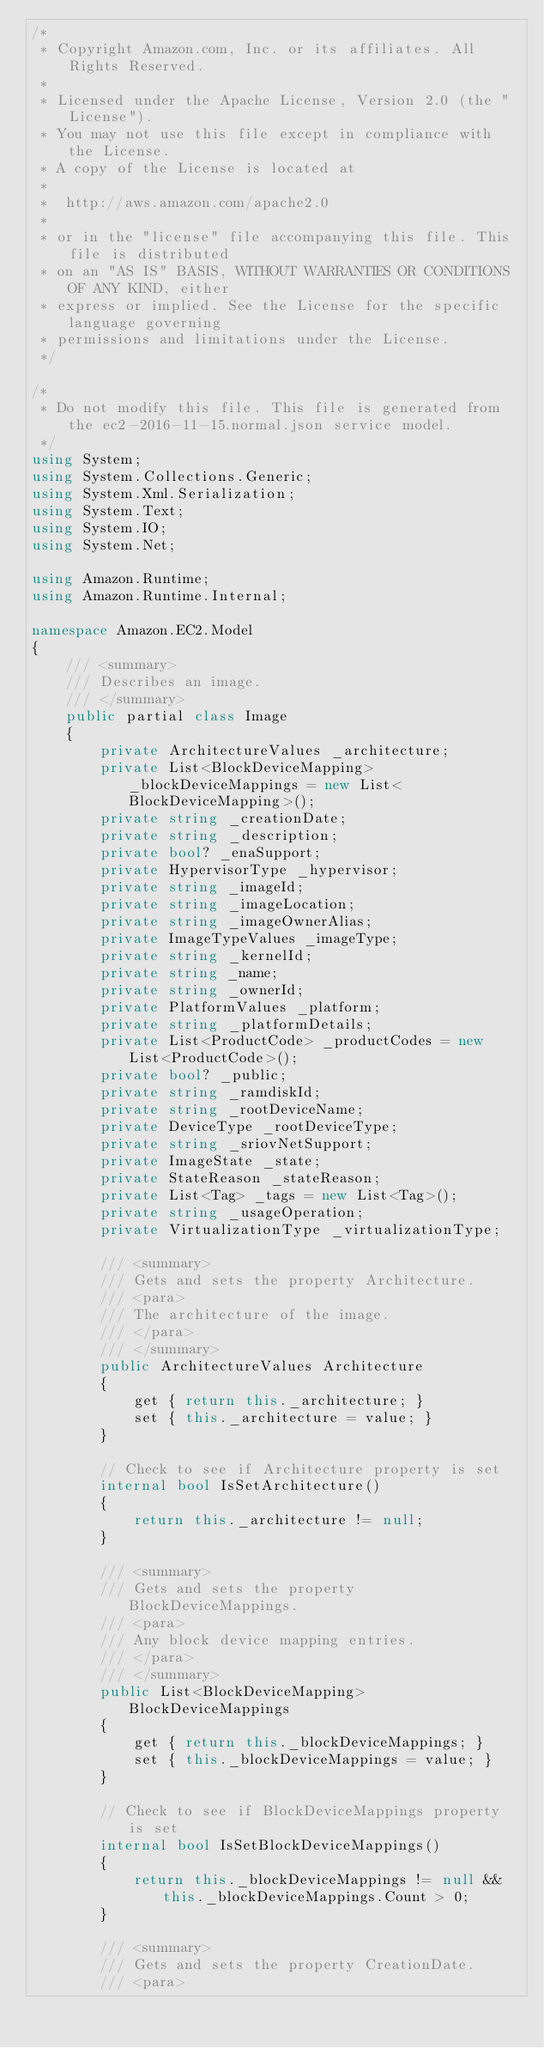<code> <loc_0><loc_0><loc_500><loc_500><_C#_>/*
 * Copyright Amazon.com, Inc. or its affiliates. All Rights Reserved.
 * 
 * Licensed under the Apache License, Version 2.0 (the "License").
 * You may not use this file except in compliance with the License.
 * A copy of the License is located at
 * 
 *  http://aws.amazon.com/apache2.0
 * 
 * or in the "license" file accompanying this file. This file is distributed
 * on an "AS IS" BASIS, WITHOUT WARRANTIES OR CONDITIONS OF ANY KIND, either
 * express or implied. See the License for the specific language governing
 * permissions and limitations under the License.
 */

/*
 * Do not modify this file. This file is generated from the ec2-2016-11-15.normal.json service model.
 */
using System;
using System.Collections.Generic;
using System.Xml.Serialization;
using System.Text;
using System.IO;
using System.Net;

using Amazon.Runtime;
using Amazon.Runtime.Internal;

namespace Amazon.EC2.Model
{
    /// <summary>
    /// Describes an image.
    /// </summary>
    public partial class Image
    {
        private ArchitectureValues _architecture;
        private List<BlockDeviceMapping> _blockDeviceMappings = new List<BlockDeviceMapping>();
        private string _creationDate;
        private string _description;
        private bool? _enaSupport;
        private HypervisorType _hypervisor;
        private string _imageId;
        private string _imageLocation;
        private string _imageOwnerAlias;
        private ImageTypeValues _imageType;
        private string _kernelId;
        private string _name;
        private string _ownerId;
        private PlatformValues _platform;
        private string _platformDetails;
        private List<ProductCode> _productCodes = new List<ProductCode>();
        private bool? _public;
        private string _ramdiskId;
        private string _rootDeviceName;
        private DeviceType _rootDeviceType;
        private string _sriovNetSupport;
        private ImageState _state;
        private StateReason _stateReason;
        private List<Tag> _tags = new List<Tag>();
        private string _usageOperation;
        private VirtualizationType _virtualizationType;

        /// <summary>
        /// Gets and sets the property Architecture. 
        /// <para>
        /// The architecture of the image.
        /// </para>
        /// </summary>
        public ArchitectureValues Architecture
        {
            get { return this._architecture; }
            set { this._architecture = value; }
        }

        // Check to see if Architecture property is set
        internal bool IsSetArchitecture()
        {
            return this._architecture != null;
        }

        /// <summary>
        /// Gets and sets the property BlockDeviceMappings. 
        /// <para>
        /// Any block device mapping entries.
        /// </para>
        /// </summary>
        public List<BlockDeviceMapping> BlockDeviceMappings
        {
            get { return this._blockDeviceMappings; }
            set { this._blockDeviceMappings = value; }
        }

        // Check to see if BlockDeviceMappings property is set
        internal bool IsSetBlockDeviceMappings()
        {
            return this._blockDeviceMappings != null && this._blockDeviceMappings.Count > 0; 
        }

        /// <summary>
        /// Gets and sets the property CreationDate. 
        /// <para></code> 